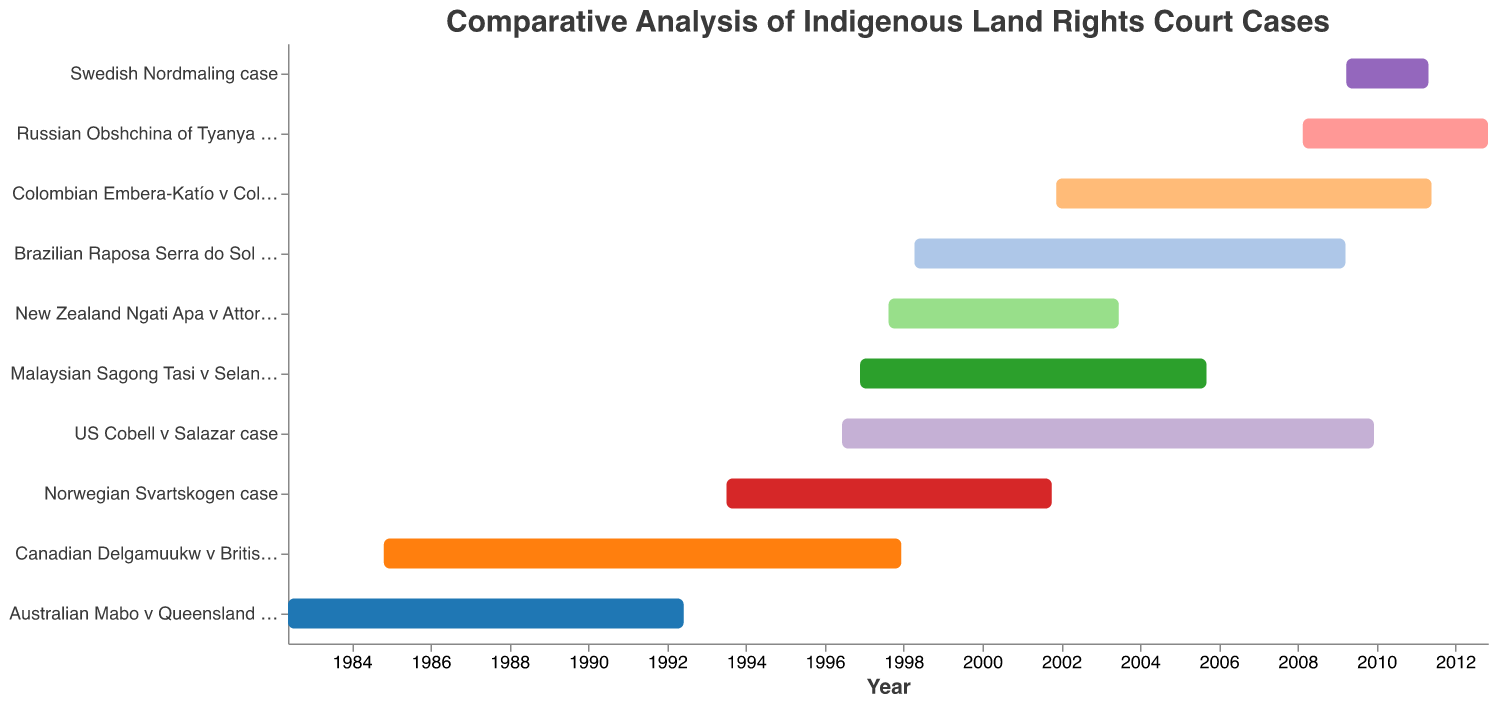What is the range of years displayed on the x-axis of the chart? The x-axis of the chart displays the time span from the earliest start date to the latest end date of the court cases. The case with the earliest start date is the Australian Mabo v Queensland case starting in 1982, and the case with the latest end date is the Russian Obshchina of Tyanya v Russia case ending in 2012.
Answer: 1982 to 2012 Which case took the longest time to resolve, and how many years did it take? To find the longest case, we need to calculate the duration of each case based on the start and end dates. The US Cobell v Salazar case took the longest, from 1996-06-10 to 2009-12-08, which is approximately 13 years and 6 months.
Answer: US Cobell v Salazar case, about 13.5 years Which case had the shortest duration, and how many years did it take? To find the shortest case, we again calculate the durations. The Swedish Nordmaling case took approximately 2 years and 1 month from 2009-03-27 to 2011-04-27.
Answer: Swedish Nordmaling case, about 2 years and 1 month How do the durations of the Australian and the Canadian cases compare? The Australian Mabo v Queensland case lasted from 1982-05-20 to 1992-06-03, approximately 10 years and 1 month. The Canadian Delgamuukw v British Columbia case lasted from 1984-10-24 to 1997-12-11, about 13 years and 2 months. Therefore, the Canadian case lasted about 3 years and 1 month longer.
Answer: The Canadian case lasted about 3 years and 1 month longer How many of the cases lasted more than 10 years? We need to count the cases whose duration exceeds 10 years. From the chart, the cases are the Australian Mabo v Queensland, Canadian Delgamuukw v British Columbia, US Cobell v Salazar, Brazilian Raposa Serra do Sol, and Colombian Embera-Katío v Colombia cases. So, there are 5 such cases.
Answer: 5 cases Which case concluded in the year 2003? By looking at the end dates in the bar chart, the New Zealand Ngati Apa v Attorney-General case ended in 2003.
Answer: New Zealand Ngati Apa v Attorney-General case What is the average duration of the court cases? To find the average duration, we sum up the durations of all the cases and divide by the number of cases. The durations are approximately: 10, 13, 13.5, 6, 11, 9, 8, 2, 9.5, and 4.5 years respectively. Summing these gives 86.5 years for 10 cases, yielding an average of 86.5 / 10 = 8.65 years.
Answer: 8.65 years Between the Colombian and the Russian cases, which one concluded first and by how many years? The Colombian Embera-Katío v Colombia case ended on 2011-05-26, and the Russian Obshchina of Tyanya v Russia case ended on 2012-10-30. Comparing these, the Colombian case concluded first, and it did so 1 year and about 5 months earlier.
Answer: Colombian case, by 1 year and 5 months 